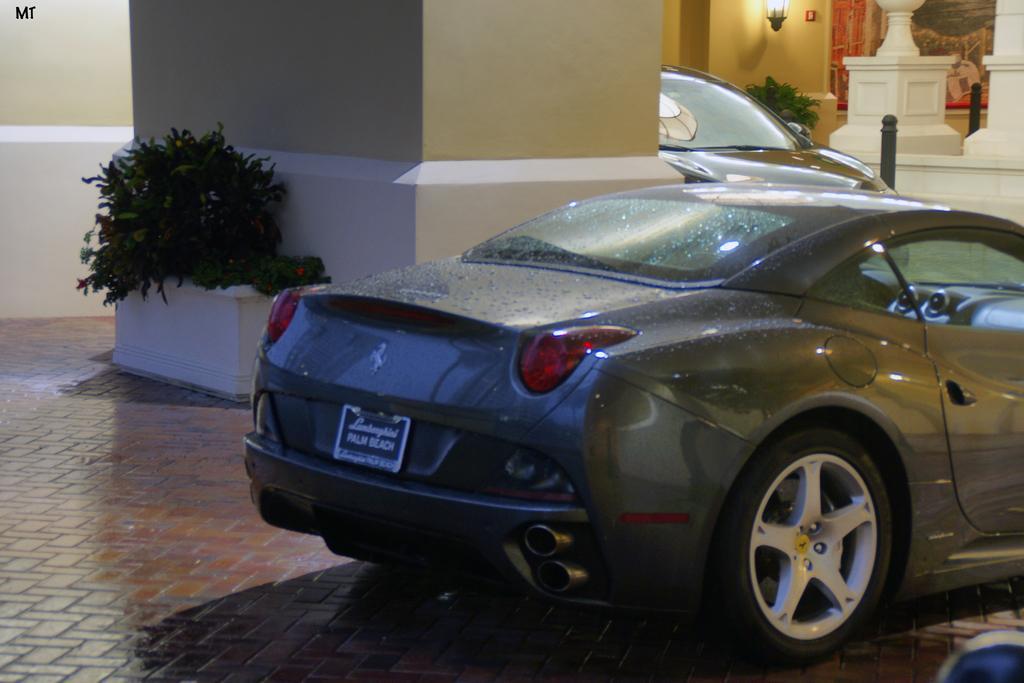Describe this image in one or two sentences. In this picture, we can see a few vehicles, ground, pillars, plants in pot, we can see the wall with lights, posters, and we can see some poles. 